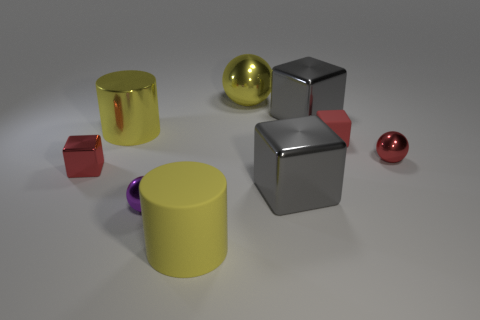What material is the gray cube that is to the right of the gray metal object that is in front of the tiny cube that is behind the red metal sphere made of?
Offer a terse response. Metal. Are there any other things that are made of the same material as the tiny purple sphere?
Give a very brief answer. Yes. Does the red ball have the same size as the rubber thing that is right of the large yellow matte cylinder?
Your response must be concise. Yes. What number of objects are either small red metal things that are to the right of the small purple thing or things that are on the left side of the large matte cylinder?
Make the answer very short. 4. There is a small shiny sphere that is behind the red shiny block; what color is it?
Offer a very short reply. Red. There is a yellow cylinder in front of the tiny purple sphere; are there any red objects that are to the right of it?
Offer a terse response. Yes. Is the number of small red matte blocks less than the number of yellow shiny objects?
Offer a terse response. Yes. There is a cube that is to the right of the gray thing behind the tiny red shiny cube; what is its material?
Your answer should be very brief. Rubber. Do the rubber cylinder and the purple metal thing have the same size?
Provide a short and direct response. No. How many things are either small cyan shiny blocks or matte things?
Your answer should be compact. 2. 